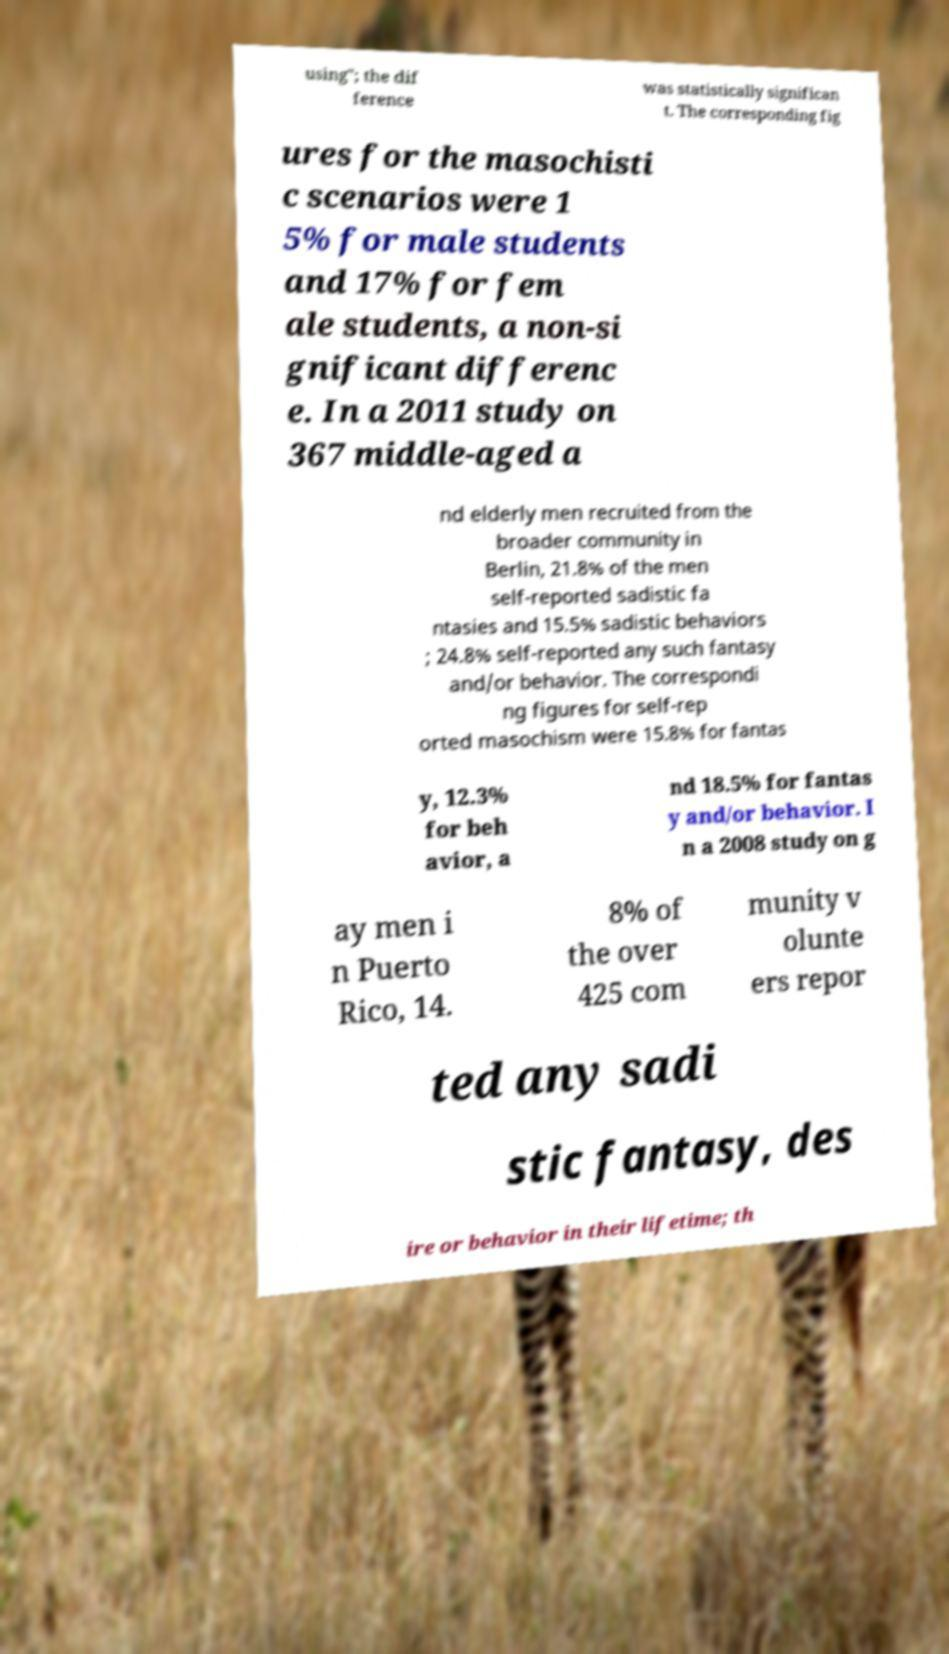I need the written content from this picture converted into text. Can you do that? using"; the dif ference was statistically significan t. The corresponding fig ures for the masochisti c scenarios were 1 5% for male students and 17% for fem ale students, a non-si gnificant differenc e. In a 2011 study on 367 middle-aged a nd elderly men recruited from the broader community in Berlin, 21.8% of the men self-reported sadistic fa ntasies and 15.5% sadistic behaviors ; 24.8% self-reported any such fantasy and/or behavior. The correspondi ng figures for self-rep orted masochism were 15.8% for fantas y, 12.3% for beh avior, a nd 18.5% for fantas y and/or behavior. I n a 2008 study on g ay men i n Puerto Rico, 14. 8% of the over 425 com munity v olunte ers repor ted any sadi stic fantasy, des ire or behavior in their lifetime; th 